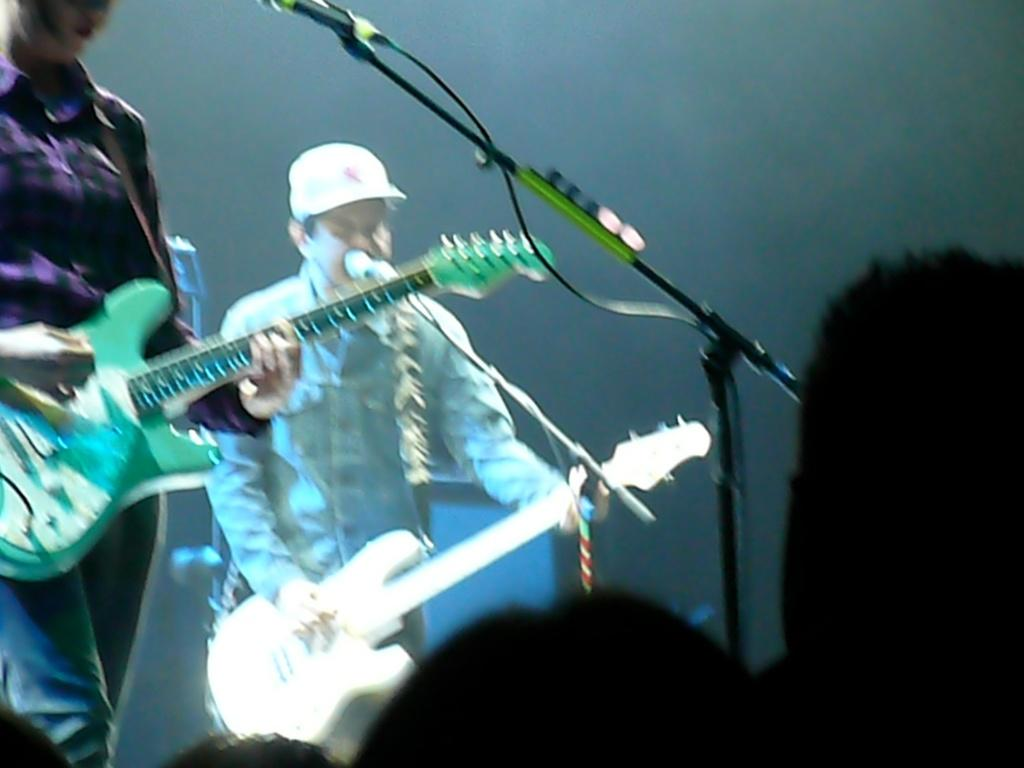How many people are playing the guitar in the image? There are two men in the image, and they are both playing the guitar. What is in front of the men while they play the guitar? There is a microphone in front of the men. Who is present in front of the men while they play the guitar? There is a crowd in front of the men. Can you see any kites flying in the image? There are no kites visible in the image. What type of lipstick is the man wearing in the image? The men in the image are not wearing lipstick, as they are playing the guitar and not depicted as wearing makeup. 